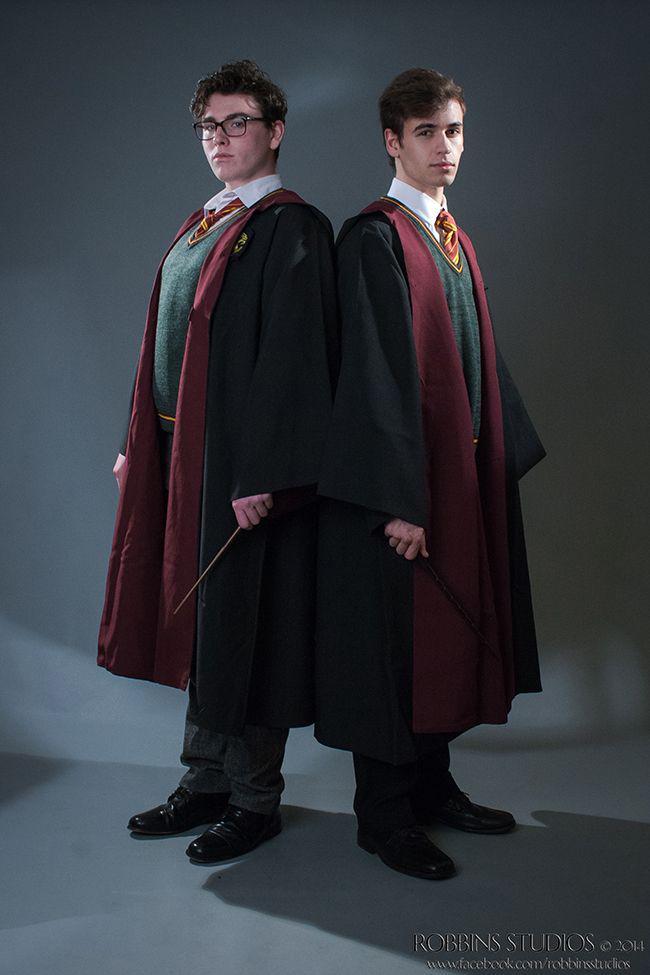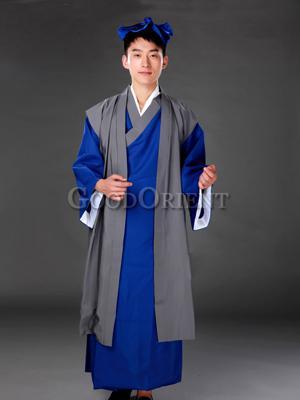The first image is the image on the left, the second image is the image on the right. Examine the images to the left and right. Is the description "The left image shows exactly one male in graduation garb." accurate? Answer yes or no. No. 